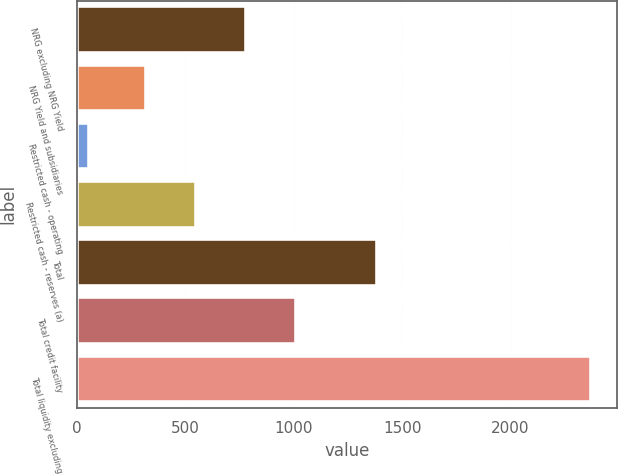Convert chart. <chart><loc_0><loc_0><loc_500><loc_500><bar_chart><fcel>NRG excluding NRG Yield<fcel>NRG Yield and subsidiaries<fcel>Restricted cash - operating<fcel>Restricted cash - reserves (a)<fcel>Total<fcel>Total credit facility<fcel>Total liquidity excluding<nl><fcel>780.4<fcel>317<fcel>56<fcel>548.7<fcel>1384<fcel>1012.1<fcel>2373<nl></chart> 